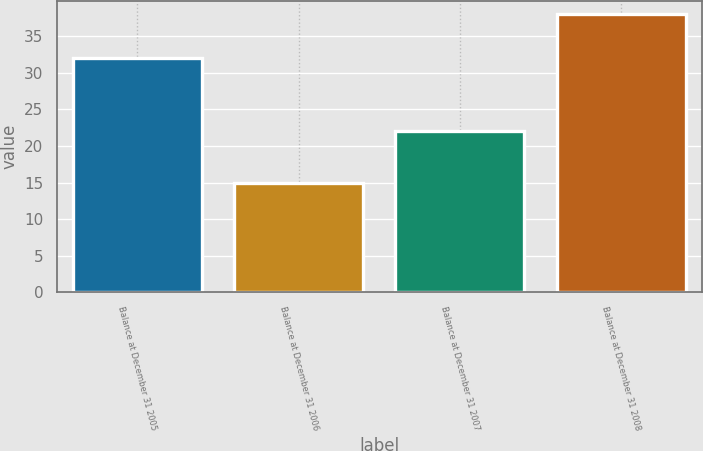Convert chart to OTSL. <chart><loc_0><loc_0><loc_500><loc_500><bar_chart><fcel>Balance at December 31 2005<fcel>Balance at December 31 2006<fcel>Balance at December 31 2007<fcel>Balance at December 31 2008<nl><fcel>32<fcel>15<fcel>22<fcel>38<nl></chart> 